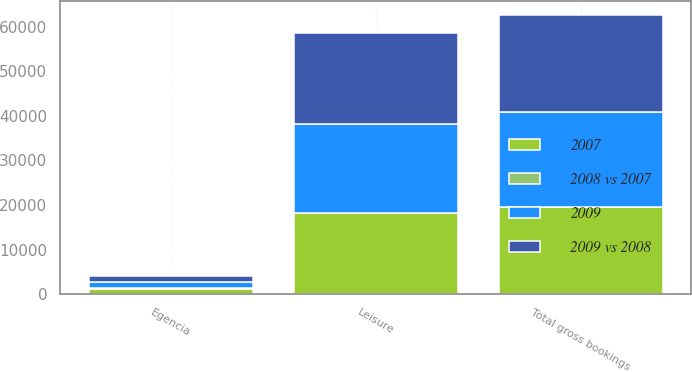Convert chart. <chart><loc_0><loc_0><loc_500><loc_500><stacked_bar_chart><ecel><fcel>Leisure<fcel>Egencia<fcel>Total gross bookings<nl><fcel>2009 vs 2008<fcel>20428<fcel>1383<fcel>21811<nl><fcel>2009<fcel>19749<fcel>1520<fcel>21269<nl><fcel>2007<fcel>18324<fcel>1308<fcel>19632<nl><fcel>2008 vs 2007<fcel>3<fcel>9<fcel>3<nl></chart> 